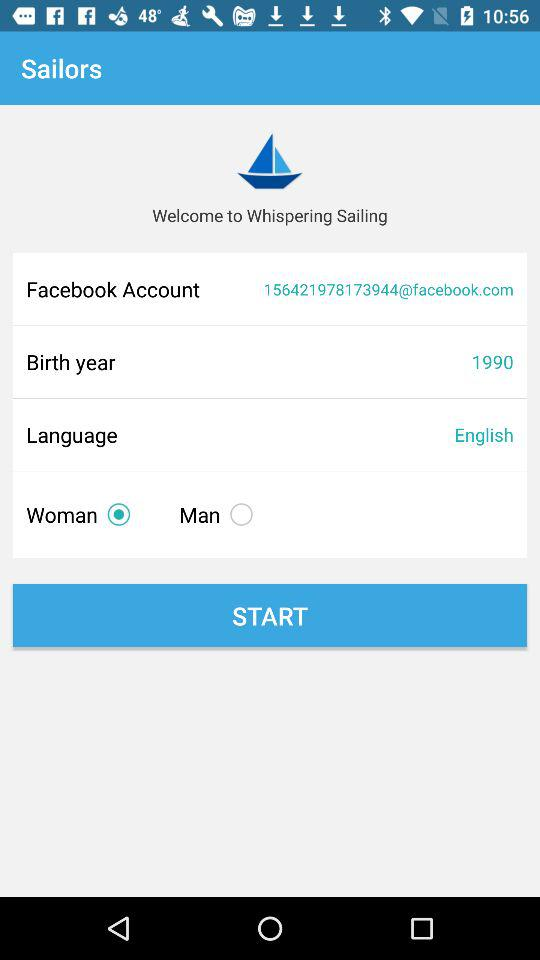What is the Facebook account? The Facebook account is 156421978173944@facebook.com. 